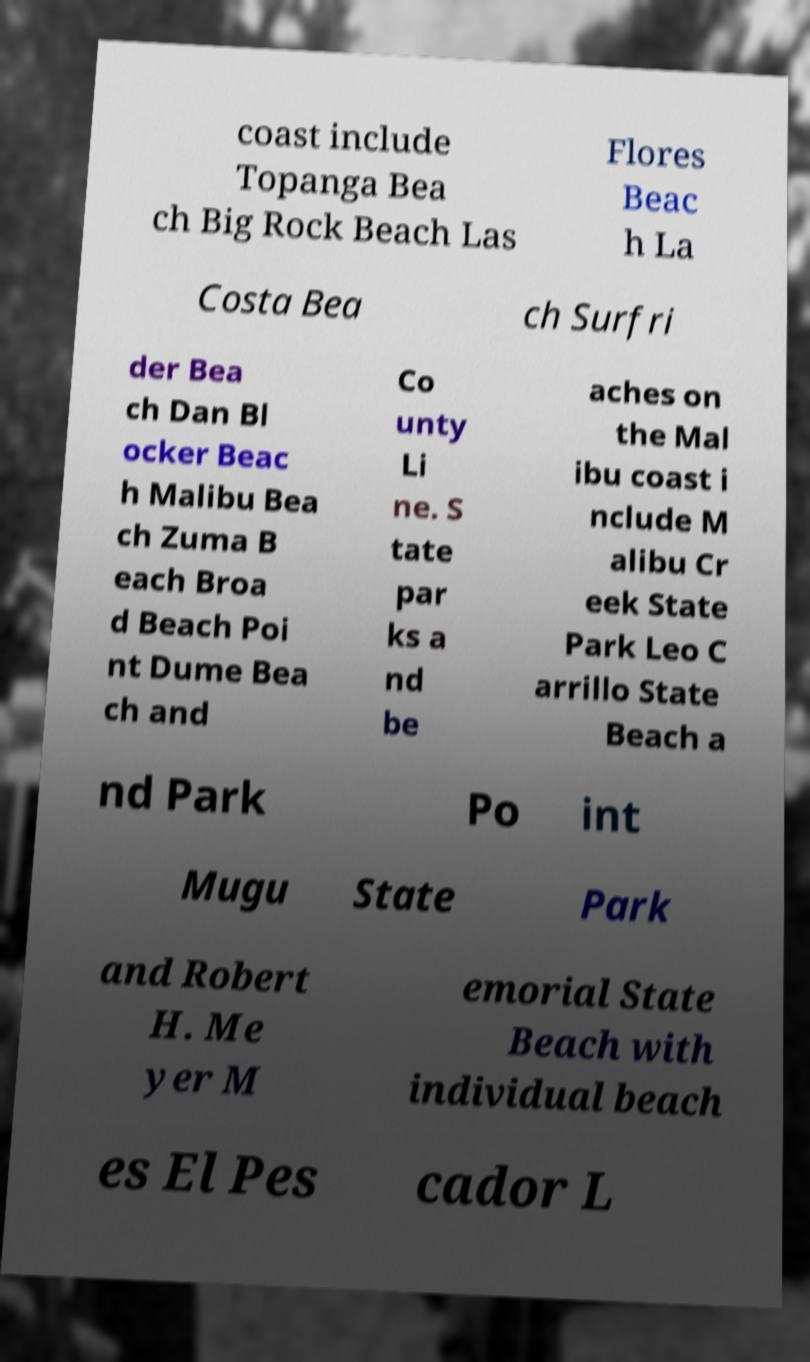Please identify and transcribe the text found in this image. coast include Topanga Bea ch Big Rock Beach Las Flores Beac h La Costa Bea ch Surfri der Bea ch Dan Bl ocker Beac h Malibu Bea ch Zuma B each Broa d Beach Poi nt Dume Bea ch and Co unty Li ne. S tate par ks a nd be aches on the Mal ibu coast i nclude M alibu Cr eek State Park Leo C arrillo State Beach a nd Park Po int Mugu State Park and Robert H. Me yer M emorial State Beach with individual beach es El Pes cador L 